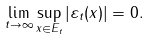<formula> <loc_0><loc_0><loc_500><loc_500>\lim _ { t \to \infty } \sup _ { x \in E _ { t } } | \varepsilon _ { t } ( x ) | = 0 .</formula> 